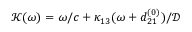<formula> <loc_0><loc_0><loc_500><loc_500>\mathcal { K } ( \omega ) = \omega / c + \kappa _ { 1 3 } ( \omega + d _ { 2 1 } ^ { ( 0 ) } ) / \mathcal { D }</formula> 